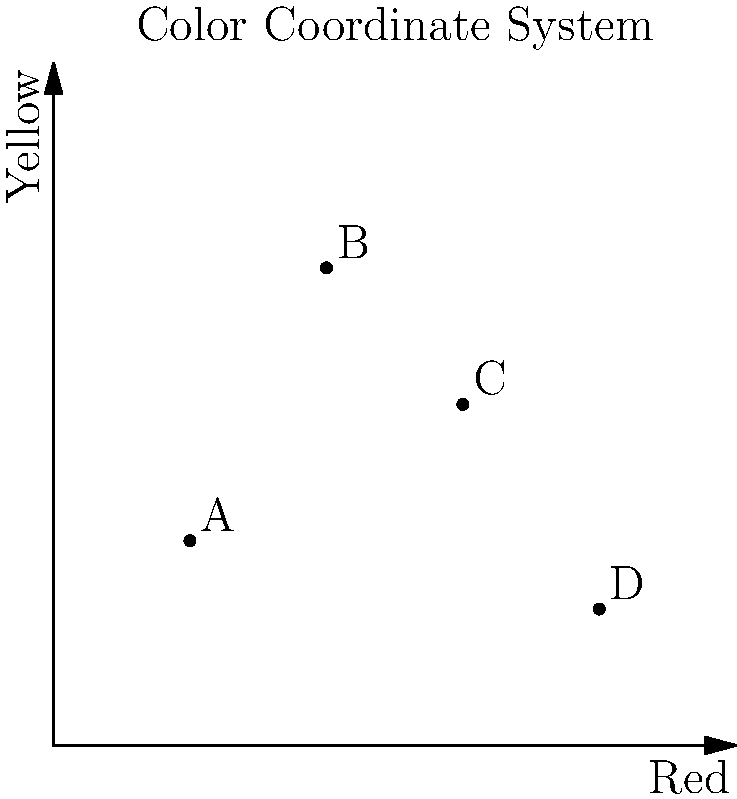In the color coordinate system shown above, the x-axis represents the intensity of red, while the y-axis represents the intensity of yellow in tulip varieties. Points A, B, C, and D represent different tulip varieties found in various regions. Which point likely represents a tulip variety with the most intense orange color? To determine which point represents the tulip variety with the most intense orange color, we need to consider the following steps:

1. Understand that orange is a mixture of red and yellow.
2. The most intense orange would have high values for both red and yellow.
3. Analyze each point's coordinates:
   A (2, 3): Low red, low yellow
   B (4, 7): Moderate red, high yellow
   C (6, 5): High red, moderate yellow
   D (8, 2): Very high red, low yellow

4. Compare the balance of red and yellow:
   - Point A has low values for both, so it's not a strong contender.
   - Point D has very high red but low yellow, likely resulting in a more reddish hue.
   - Point B has a good amount of yellow but less red, potentially resulting in a more yellowish-orange.
   - Point C has high red and moderate yellow, providing a good balance for an intense orange.

5. Conclude that Point C (6, 5) likely represents the most intense orange color due to its balanced high values for both red and yellow components.
Answer: Point C 